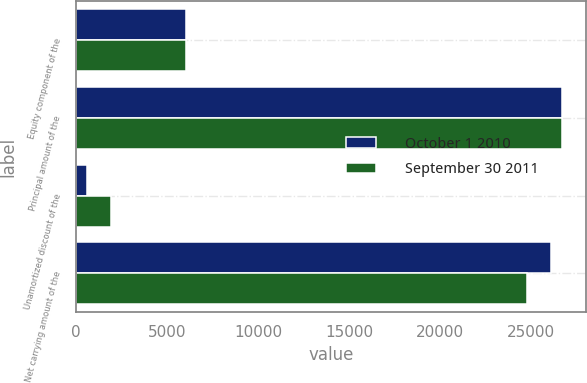Convert chart to OTSL. <chart><loc_0><loc_0><loc_500><loc_500><stacked_bar_chart><ecel><fcel>Equity component of the<fcel>Principal amount of the<fcel>Unamortized discount of the<fcel>Net carrying amount of the<nl><fcel>October 1 2010<fcel>6061<fcel>26677<fcel>588<fcel>26089<nl><fcel>September 30 2011<fcel>6061<fcel>26677<fcel>1934<fcel>24743<nl></chart> 